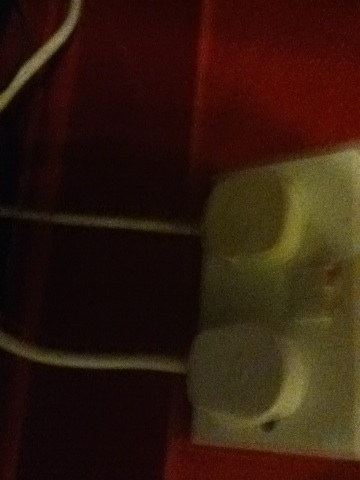What might the white object be, considering its shape and size? The white object could possibly be an electrical outlet or switch based on its rectangular shape and apparent slots. 